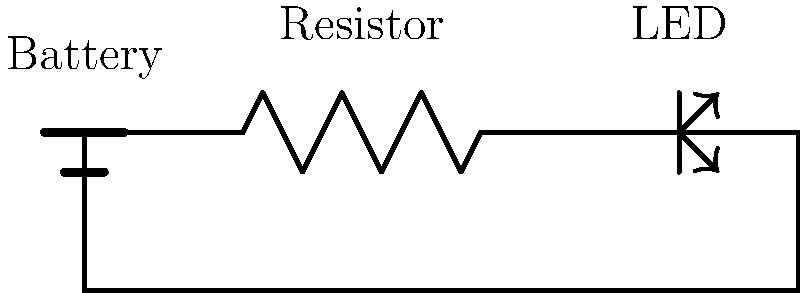In the circuit shown, what is the purpose of the resistor when connected in series with the LED? To understand the purpose of the resistor in this circuit, let's break it down step-by-step:

1. LEDs (Light Emitting Diodes) are sensitive components that require a specific amount of current to function properly.

2. The battery provides a constant voltage, but without any regulation, it could supply too much current to the LED.

3. Excess current flowing through an LED can cause it to burn out quickly or even immediately.

4. The resistor acts as a current-limiting device in the circuit.

5. By Ohm's Law, $V = IR$, where $V$ is voltage, $I$ is current, and $R$ is resistance.

6. The resistor creates a voltage drop, reducing the voltage across the LED to a safe level.

7. This, in turn, limits the current flowing through the LED to a suitable amount.

8. The specific value of the resistor is chosen based on the battery voltage, LED specifications, and desired LED brightness.

9. By including the resistor, we can protect the LED from damage and control its brightness.

10. This setup allows for a stable and safe operation of the LED in the circuit.
Answer: To limit current and protect the LED 